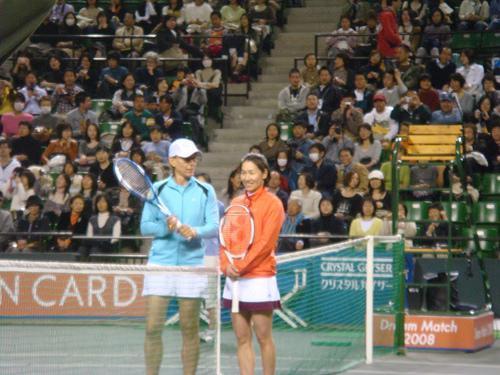How many tennis racquets do you see?
Give a very brief answer. 2. How many hands are touching the blue and white racket?
Give a very brief answer. 2. 